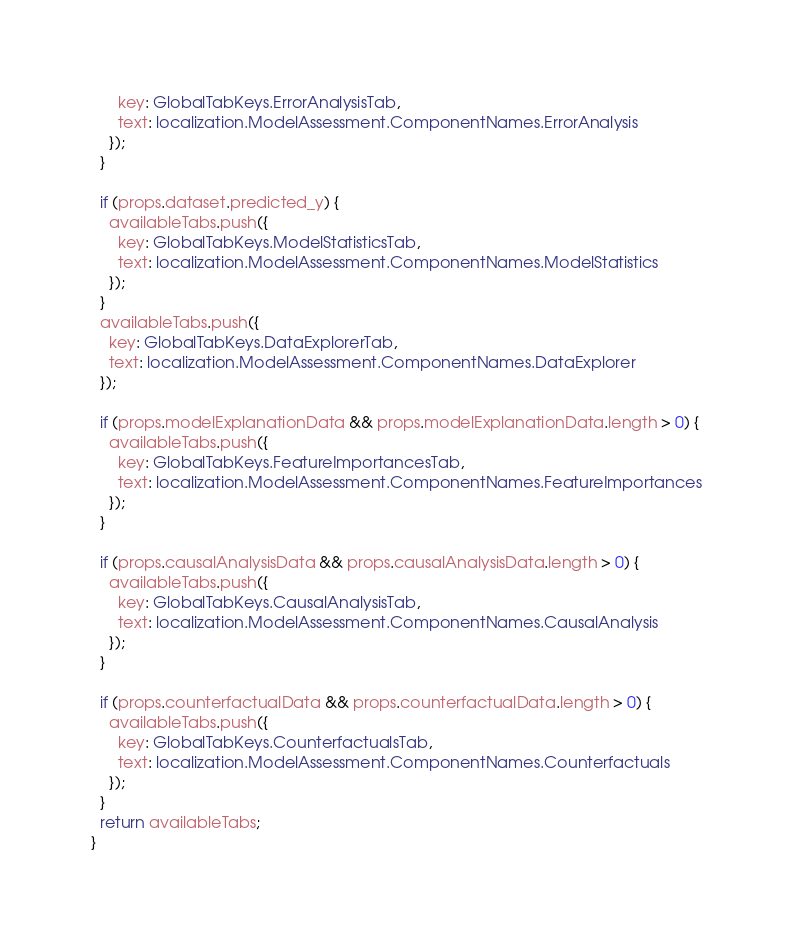Convert code to text. <code><loc_0><loc_0><loc_500><loc_500><_TypeScript_>      key: GlobalTabKeys.ErrorAnalysisTab,
      text: localization.ModelAssessment.ComponentNames.ErrorAnalysis
    });
  }

  if (props.dataset.predicted_y) {
    availableTabs.push({
      key: GlobalTabKeys.ModelStatisticsTab,
      text: localization.ModelAssessment.ComponentNames.ModelStatistics
    });
  }
  availableTabs.push({
    key: GlobalTabKeys.DataExplorerTab,
    text: localization.ModelAssessment.ComponentNames.DataExplorer
  });

  if (props.modelExplanationData && props.modelExplanationData.length > 0) {
    availableTabs.push({
      key: GlobalTabKeys.FeatureImportancesTab,
      text: localization.ModelAssessment.ComponentNames.FeatureImportances
    });
  }

  if (props.causalAnalysisData && props.causalAnalysisData.length > 0) {
    availableTabs.push({
      key: GlobalTabKeys.CausalAnalysisTab,
      text: localization.ModelAssessment.ComponentNames.CausalAnalysis
    });
  }

  if (props.counterfactualData && props.counterfactualData.length > 0) {
    availableTabs.push({
      key: GlobalTabKeys.CounterfactualsTab,
      text: localization.ModelAssessment.ComponentNames.Counterfactuals
    });
  }
  return availableTabs;
}
</code> 